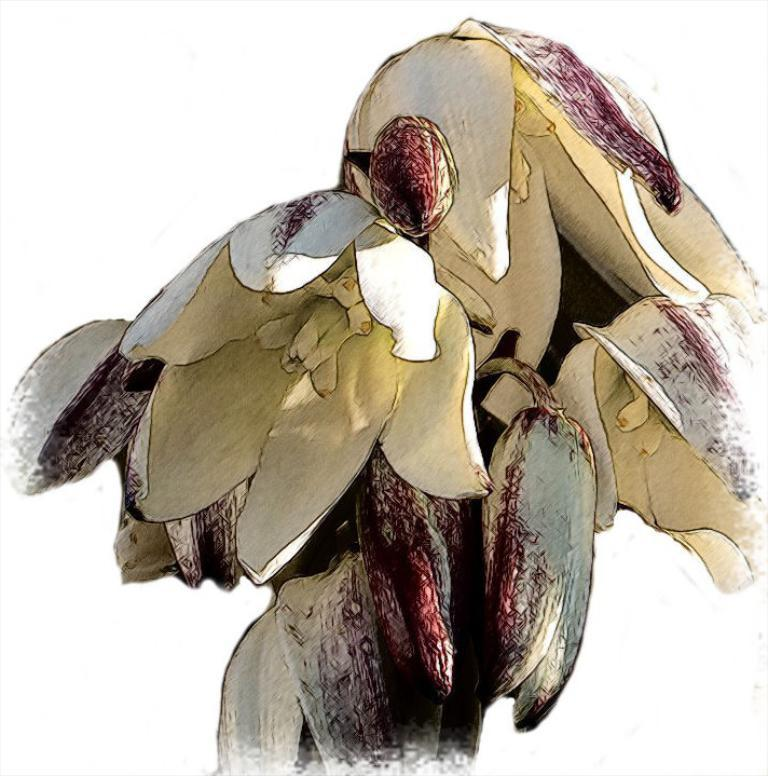What type of living organisms can be seen in the image? There are flowers in the image. What color is the background of the image? The background of the image is white. What type of ice can be seen melting in the image? There is no ice present in the image; it only features flowers and a white background. 